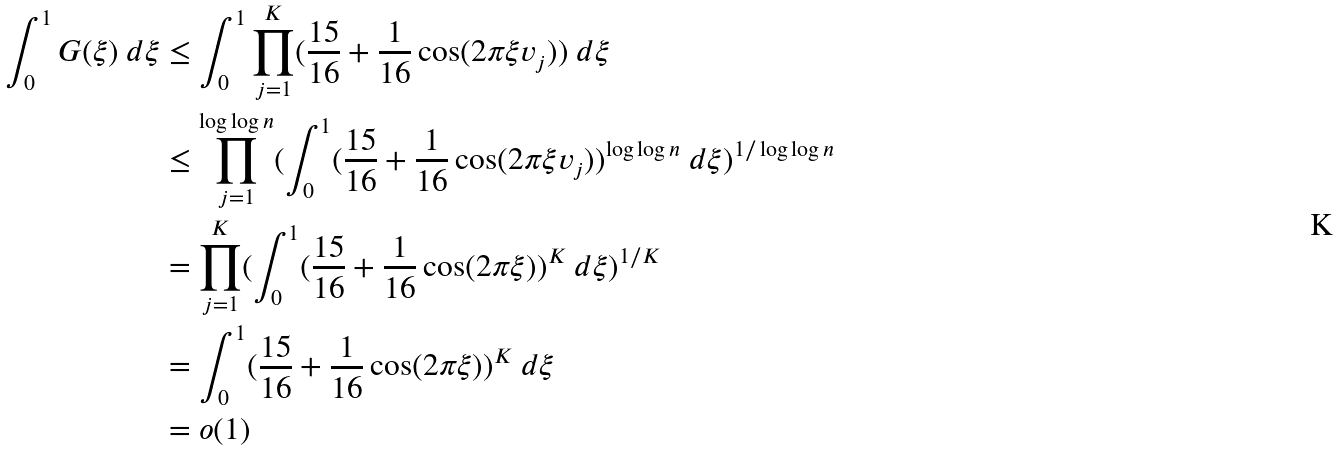Convert formula to latex. <formula><loc_0><loc_0><loc_500><loc_500>\int _ { 0 } ^ { 1 } G ( \xi ) \ d \xi & \leq \int _ { 0 } ^ { 1 } \prod _ { j = 1 } ^ { K } ( \frac { 1 5 } { 1 6 } + \frac { 1 } { 1 6 } \cos ( 2 \pi \xi v _ { j } ) ) \ d \xi \\ & \leq \prod _ { j = 1 } ^ { \log \log n } ( \int _ { 0 } ^ { 1 } ( \frac { 1 5 } { 1 6 } + \frac { 1 } { 1 6 } \cos ( 2 \pi \xi v _ { j } ) ) ^ { \log \log n } \ d \xi ) ^ { 1 / \log \log n } \\ & = \prod _ { j = 1 } ^ { K } ( \int _ { 0 } ^ { 1 } ( \frac { 1 5 } { 1 6 } + \frac { 1 } { 1 6 } \cos ( 2 \pi \xi ) ) ^ { K } \ d \xi ) ^ { 1 / { K } } \\ & = \int _ { 0 } ^ { 1 } ( \frac { 1 5 } { 1 6 } + \frac { 1 } { 1 6 } \cos ( 2 \pi \xi ) ) ^ { K } \ d \xi \\ & = o ( 1 )</formula> 